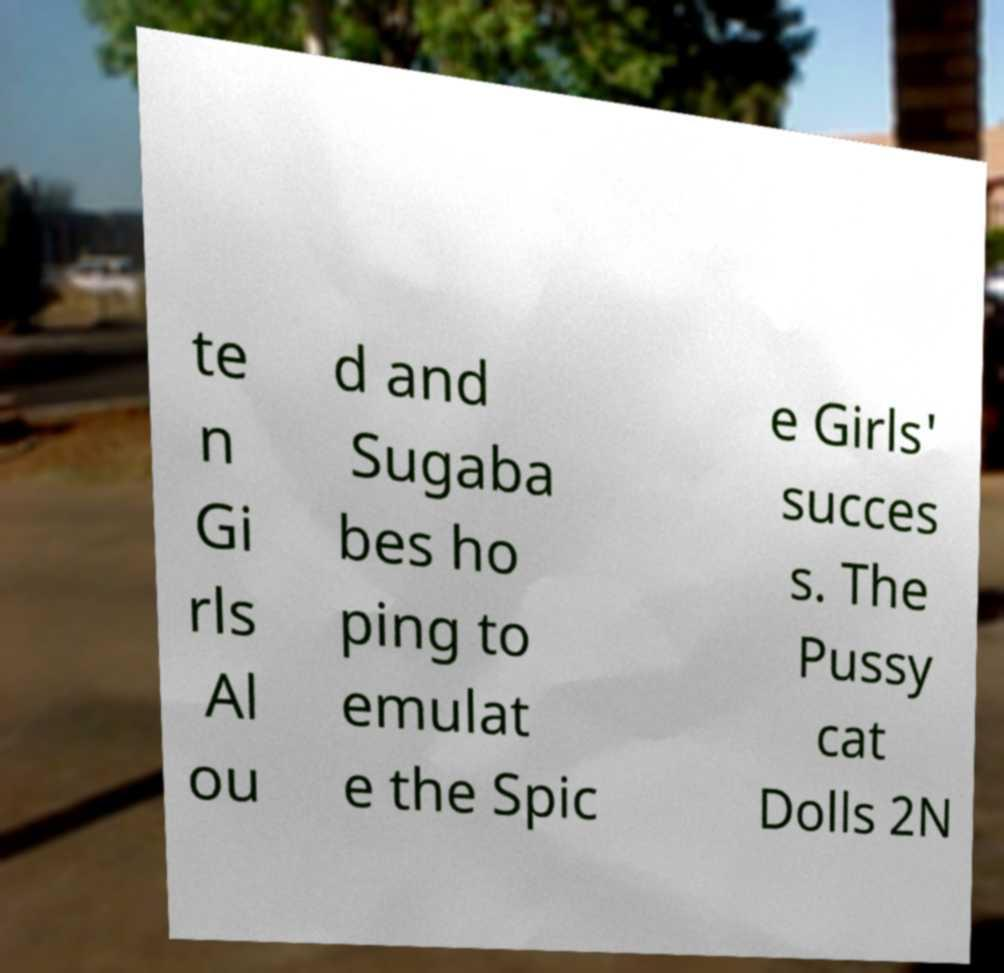Can you read and provide the text displayed in the image?This photo seems to have some interesting text. Can you extract and type it out for me? te n Gi rls Al ou d and Sugaba bes ho ping to emulat e the Spic e Girls' succes s. The Pussy cat Dolls 2N 